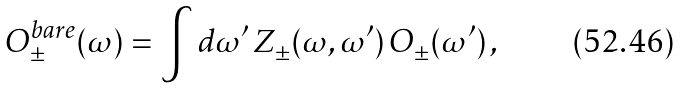<formula> <loc_0><loc_0><loc_500><loc_500>O ^ { \text {bare} } _ { \pm } ( \omega ) = \int \text {d} \omega ^ { \prime } \, Z _ { \pm } ( \omega , \omega ^ { \prime } ) \, O _ { \pm } ( \omega ^ { \prime } ) \, ,</formula> 